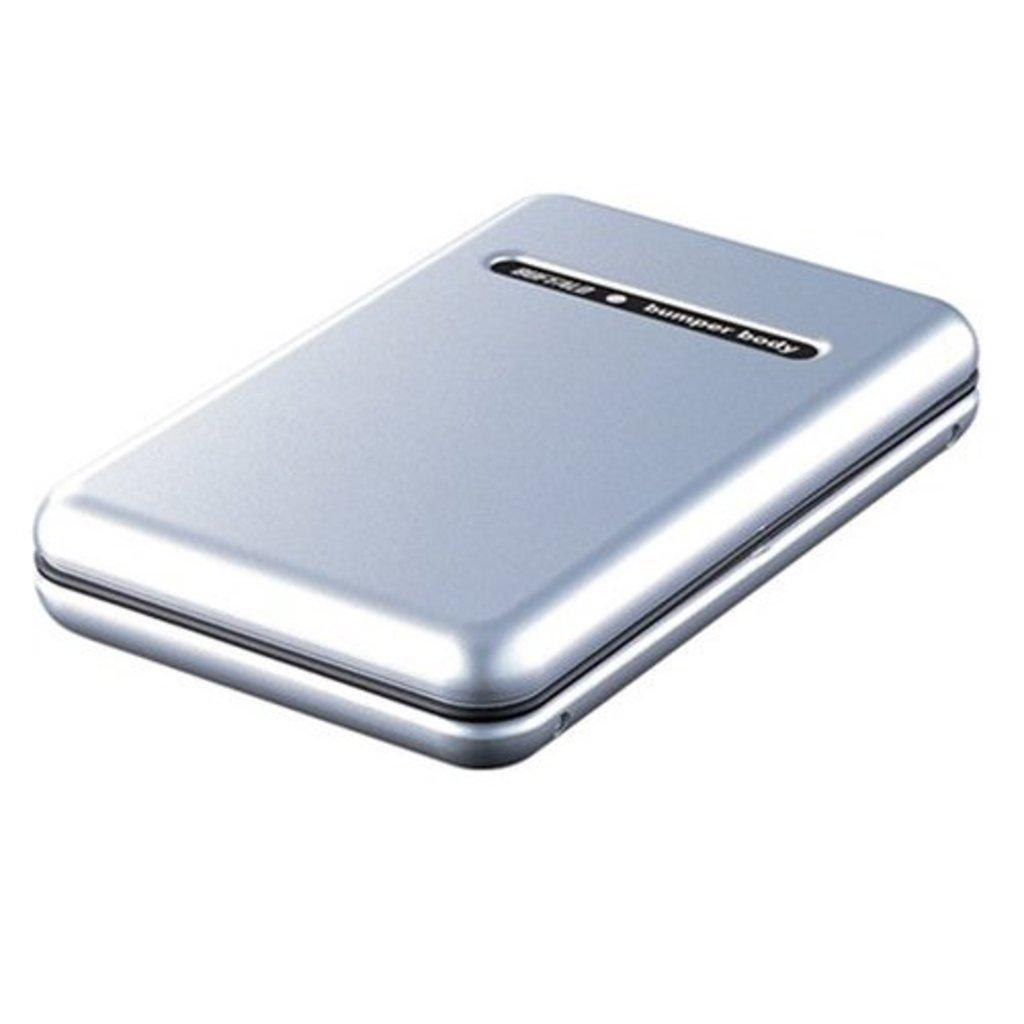Provide a one-sentence caption for the provided image. A small device in a chrome color is labelled as Bumper Body. 